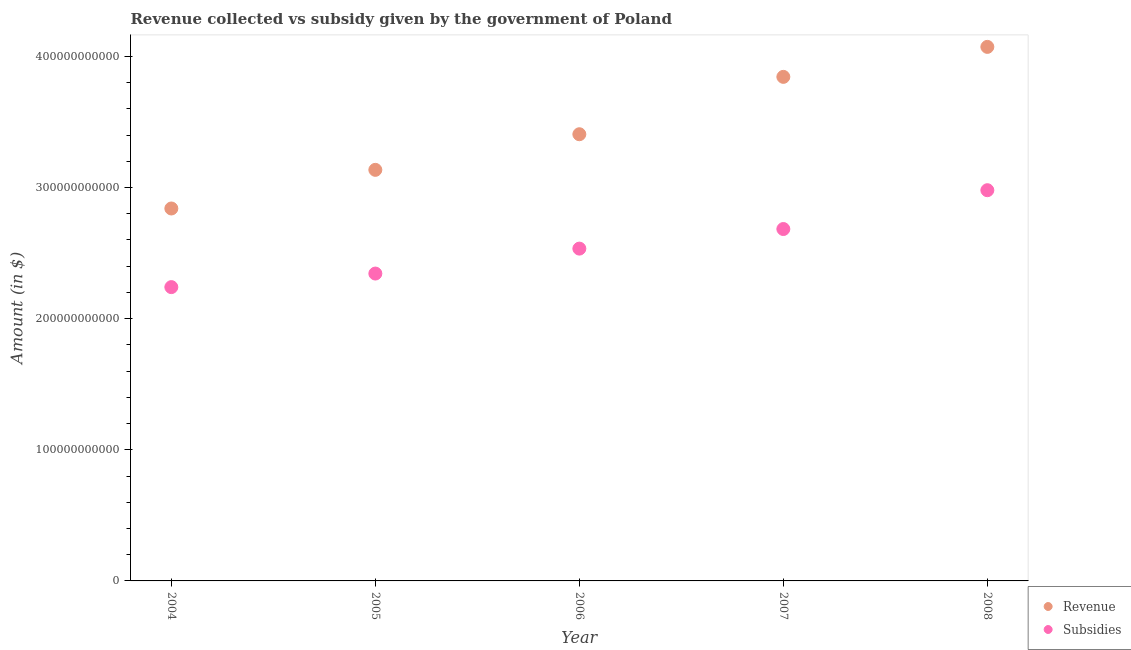Is the number of dotlines equal to the number of legend labels?
Provide a short and direct response. Yes. What is the amount of revenue collected in 2006?
Make the answer very short. 3.41e+11. Across all years, what is the maximum amount of subsidies given?
Your answer should be very brief. 2.98e+11. Across all years, what is the minimum amount of revenue collected?
Your response must be concise. 2.84e+11. In which year was the amount of revenue collected maximum?
Your answer should be compact. 2008. What is the total amount of revenue collected in the graph?
Make the answer very short. 1.73e+12. What is the difference between the amount of subsidies given in 2004 and that in 2006?
Your answer should be compact. -2.94e+1. What is the difference between the amount of subsidies given in 2006 and the amount of revenue collected in 2008?
Provide a short and direct response. -1.54e+11. What is the average amount of subsidies given per year?
Make the answer very short. 2.56e+11. In the year 2005, what is the difference between the amount of subsidies given and amount of revenue collected?
Your answer should be very brief. -7.91e+1. In how many years, is the amount of revenue collected greater than 220000000000 $?
Provide a succinct answer. 5. What is the ratio of the amount of subsidies given in 2006 to that in 2008?
Offer a very short reply. 0.85. Is the amount of subsidies given in 2005 less than that in 2008?
Provide a short and direct response. Yes. Is the difference between the amount of subsidies given in 2004 and 2007 greater than the difference between the amount of revenue collected in 2004 and 2007?
Make the answer very short. Yes. What is the difference between the highest and the second highest amount of revenue collected?
Your response must be concise. 2.29e+1. What is the difference between the highest and the lowest amount of revenue collected?
Make the answer very short. 1.23e+11. Is the sum of the amount of revenue collected in 2005 and 2006 greater than the maximum amount of subsidies given across all years?
Provide a short and direct response. Yes. Does the amount of subsidies given monotonically increase over the years?
Provide a short and direct response. Yes. Is the amount of revenue collected strictly less than the amount of subsidies given over the years?
Offer a terse response. No. How many dotlines are there?
Ensure brevity in your answer.  2. How many years are there in the graph?
Keep it short and to the point. 5. What is the difference between two consecutive major ticks on the Y-axis?
Your answer should be compact. 1.00e+11. Are the values on the major ticks of Y-axis written in scientific E-notation?
Your response must be concise. No. Does the graph contain any zero values?
Make the answer very short. No. What is the title of the graph?
Provide a succinct answer. Revenue collected vs subsidy given by the government of Poland. What is the label or title of the X-axis?
Give a very brief answer. Year. What is the label or title of the Y-axis?
Make the answer very short. Amount (in $). What is the Amount (in $) in Revenue in 2004?
Give a very brief answer. 2.84e+11. What is the Amount (in $) in Subsidies in 2004?
Your answer should be compact. 2.24e+11. What is the Amount (in $) in Revenue in 2005?
Offer a very short reply. 3.13e+11. What is the Amount (in $) of Subsidies in 2005?
Provide a short and direct response. 2.34e+11. What is the Amount (in $) of Revenue in 2006?
Make the answer very short. 3.41e+11. What is the Amount (in $) of Subsidies in 2006?
Your answer should be very brief. 2.53e+11. What is the Amount (in $) in Revenue in 2007?
Your response must be concise. 3.84e+11. What is the Amount (in $) in Subsidies in 2007?
Provide a short and direct response. 2.68e+11. What is the Amount (in $) of Revenue in 2008?
Give a very brief answer. 4.07e+11. What is the Amount (in $) of Subsidies in 2008?
Offer a very short reply. 2.98e+11. Across all years, what is the maximum Amount (in $) in Revenue?
Provide a short and direct response. 4.07e+11. Across all years, what is the maximum Amount (in $) in Subsidies?
Provide a succinct answer. 2.98e+11. Across all years, what is the minimum Amount (in $) in Revenue?
Your answer should be very brief. 2.84e+11. Across all years, what is the minimum Amount (in $) in Subsidies?
Give a very brief answer. 2.24e+11. What is the total Amount (in $) in Revenue in the graph?
Provide a short and direct response. 1.73e+12. What is the total Amount (in $) of Subsidies in the graph?
Keep it short and to the point. 1.28e+12. What is the difference between the Amount (in $) of Revenue in 2004 and that in 2005?
Your answer should be compact. -2.95e+1. What is the difference between the Amount (in $) in Subsidies in 2004 and that in 2005?
Give a very brief answer. -1.03e+1. What is the difference between the Amount (in $) of Revenue in 2004 and that in 2006?
Offer a terse response. -5.66e+1. What is the difference between the Amount (in $) of Subsidies in 2004 and that in 2006?
Your answer should be compact. -2.94e+1. What is the difference between the Amount (in $) in Revenue in 2004 and that in 2007?
Offer a terse response. -1.00e+11. What is the difference between the Amount (in $) of Subsidies in 2004 and that in 2007?
Make the answer very short. -4.43e+1. What is the difference between the Amount (in $) in Revenue in 2004 and that in 2008?
Provide a succinct answer. -1.23e+11. What is the difference between the Amount (in $) in Subsidies in 2004 and that in 2008?
Ensure brevity in your answer.  -7.39e+1. What is the difference between the Amount (in $) of Revenue in 2005 and that in 2006?
Keep it short and to the point. -2.72e+1. What is the difference between the Amount (in $) of Subsidies in 2005 and that in 2006?
Provide a short and direct response. -1.90e+1. What is the difference between the Amount (in $) of Revenue in 2005 and that in 2007?
Provide a short and direct response. -7.09e+1. What is the difference between the Amount (in $) of Subsidies in 2005 and that in 2007?
Keep it short and to the point. -3.40e+1. What is the difference between the Amount (in $) in Revenue in 2005 and that in 2008?
Offer a terse response. -9.38e+1. What is the difference between the Amount (in $) of Subsidies in 2005 and that in 2008?
Keep it short and to the point. -6.36e+1. What is the difference between the Amount (in $) in Revenue in 2006 and that in 2007?
Your answer should be very brief. -4.37e+1. What is the difference between the Amount (in $) of Subsidies in 2006 and that in 2007?
Provide a short and direct response. -1.49e+1. What is the difference between the Amount (in $) in Revenue in 2006 and that in 2008?
Offer a very short reply. -6.66e+1. What is the difference between the Amount (in $) of Subsidies in 2006 and that in 2008?
Keep it short and to the point. -4.45e+1. What is the difference between the Amount (in $) of Revenue in 2007 and that in 2008?
Offer a terse response. -2.29e+1. What is the difference between the Amount (in $) in Subsidies in 2007 and that in 2008?
Make the answer very short. -2.96e+1. What is the difference between the Amount (in $) of Revenue in 2004 and the Amount (in $) of Subsidies in 2005?
Give a very brief answer. 4.96e+1. What is the difference between the Amount (in $) of Revenue in 2004 and the Amount (in $) of Subsidies in 2006?
Your answer should be very brief. 3.06e+1. What is the difference between the Amount (in $) in Revenue in 2004 and the Amount (in $) in Subsidies in 2007?
Ensure brevity in your answer.  1.57e+1. What is the difference between the Amount (in $) of Revenue in 2004 and the Amount (in $) of Subsidies in 2008?
Offer a terse response. -1.39e+1. What is the difference between the Amount (in $) in Revenue in 2005 and the Amount (in $) in Subsidies in 2006?
Your response must be concise. 6.01e+1. What is the difference between the Amount (in $) in Revenue in 2005 and the Amount (in $) in Subsidies in 2007?
Provide a short and direct response. 4.51e+1. What is the difference between the Amount (in $) of Revenue in 2005 and the Amount (in $) of Subsidies in 2008?
Your answer should be compact. 1.55e+1. What is the difference between the Amount (in $) in Revenue in 2006 and the Amount (in $) in Subsidies in 2007?
Offer a very short reply. 7.23e+1. What is the difference between the Amount (in $) of Revenue in 2006 and the Amount (in $) of Subsidies in 2008?
Make the answer very short. 4.27e+1. What is the difference between the Amount (in $) in Revenue in 2007 and the Amount (in $) in Subsidies in 2008?
Offer a very short reply. 8.64e+1. What is the average Amount (in $) of Revenue per year?
Offer a terse response. 3.46e+11. What is the average Amount (in $) in Subsidies per year?
Ensure brevity in your answer.  2.56e+11. In the year 2004, what is the difference between the Amount (in $) in Revenue and Amount (in $) in Subsidies?
Offer a terse response. 6.00e+1. In the year 2005, what is the difference between the Amount (in $) in Revenue and Amount (in $) in Subsidies?
Your answer should be compact. 7.91e+1. In the year 2006, what is the difference between the Amount (in $) of Revenue and Amount (in $) of Subsidies?
Your answer should be compact. 8.72e+1. In the year 2007, what is the difference between the Amount (in $) of Revenue and Amount (in $) of Subsidies?
Provide a short and direct response. 1.16e+11. In the year 2008, what is the difference between the Amount (in $) in Revenue and Amount (in $) in Subsidies?
Your answer should be very brief. 1.09e+11. What is the ratio of the Amount (in $) of Revenue in 2004 to that in 2005?
Make the answer very short. 0.91. What is the ratio of the Amount (in $) in Subsidies in 2004 to that in 2005?
Provide a succinct answer. 0.96. What is the ratio of the Amount (in $) in Revenue in 2004 to that in 2006?
Ensure brevity in your answer.  0.83. What is the ratio of the Amount (in $) in Subsidies in 2004 to that in 2006?
Offer a terse response. 0.88. What is the ratio of the Amount (in $) in Revenue in 2004 to that in 2007?
Your answer should be compact. 0.74. What is the ratio of the Amount (in $) in Subsidies in 2004 to that in 2007?
Your answer should be compact. 0.83. What is the ratio of the Amount (in $) in Revenue in 2004 to that in 2008?
Provide a short and direct response. 0.7. What is the ratio of the Amount (in $) of Subsidies in 2004 to that in 2008?
Offer a terse response. 0.75. What is the ratio of the Amount (in $) in Revenue in 2005 to that in 2006?
Offer a very short reply. 0.92. What is the ratio of the Amount (in $) of Subsidies in 2005 to that in 2006?
Give a very brief answer. 0.92. What is the ratio of the Amount (in $) in Revenue in 2005 to that in 2007?
Provide a succinct answer. 0.82. What is the ratio of the Amount (in $) in Subsidies in 2005 to that in 2007?
Your answer should be very brief. 0.87. What is the ratio of the Amount (in $) in Revenue in 2005 to that in 2008?
Keep it short and to the point. 0.77. What is the ratio of the Amount (in $) in Subsidies in 2005 to that in 2008?
Offer a terse response. 0.79. What is the ratio of the Amount (in $) in Revenue in 2006 to that in 2007?
Give a very brief answer. 0.89. What is the ratio of the Amount (in $) of Subsidies in 2006 to that in 2007?
Ensure brevity in your answer.  0.94. What is the ratio of the Amount (in $) in Revenue in 2006 to that in 2008?
Provide a succinct answer. 0.84. What is the ratio of the Amount (in $) of Subsidies in 2006 to that in 2008?
Keep it short and to the point. 0.85. What is the ratio of the Amount (in $) in Revenue in 2007 to that in 2008?
Your answer should be very brief. 0.94. What is the ratio of the Amount (in $) of Subsidies in 2007 to that in 2008?
Ensure brevity in your answer.  0.9. What is the difference between the highest and the second highest Amount (in $) of Revenue?
Give a very brief answer. 2.29e+1. What is the difference between the highest and the second highest Amount (in $) in Subsidies?
Your answer should be very brief. 2.96e+1. What is the difference between the highest and the lowest Amount (in $) in Revenue?
Keep it short and to the point. 1.23e+11. What is the difference between the highest and the lowest Amount (in $) of Subsidies?
Ensure brevity in your answer.  7.39e+1. 